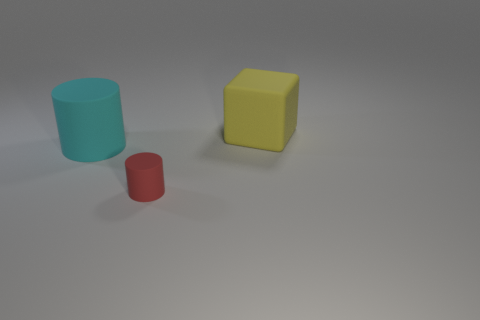Are there any other things that are the same size as the red rubber object?
Your answer should be compact. No. Does the cyan object have the same size as the matte thing on the right side of the red matte thing?
Your response must be concise. Yes. Is there a large cube made of the same material as the large cyan cylinder?
Give a very brief answer. Yes. How many cubes are either big yellow matte objects or tiny red matte things?
Give a very brief answer. 1. Is there a red cylinder that is in front of the large thing on the left side of the big yellow rubber block?
Give a very brief answer. Yes. Are there fewer red rubber objects than cylinders?
Offer a very short reply. Yes. How many cyan rubber things have the same shape as the yellow rubber object?
Give a very brief answer. 0. How many purple things are either small objects or large matte spheres?
Your answer should be very brief. 0. How big is the cylinder left of the object that is in front of the cyan matte cylinder?
Provide a short and direct response. Large. There is a big thing that is the same shape as the tiny thing; what is its material?
Offer a very short reply. Rubber. 